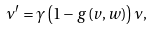Convert formula to latex. <formula><loc_0><loc_0><loc_500><loc_500>\nu ^ { \prime } = \gamma \left ( 1 - g \left ( v , w \right ) \right ) \nu ,</formula> 